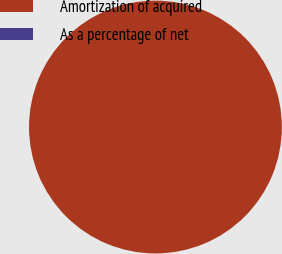Convert chart. <chart><loc_0><loc_0><loc_500><loc_500><pie_chart><fcel>Amortization of acquired<fcel>As a percentage of net<nl><fcel>100.0%<fcel>0.0%<nl></chart> 